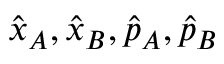Convert formula to latex. <formula><loc_0><loc_0><loc_500><loc_500>\hat { x } _ { A } , \hat { x } _ { B } , \hat { p } _ { A } , \hat { p } _ { B }</formula> 